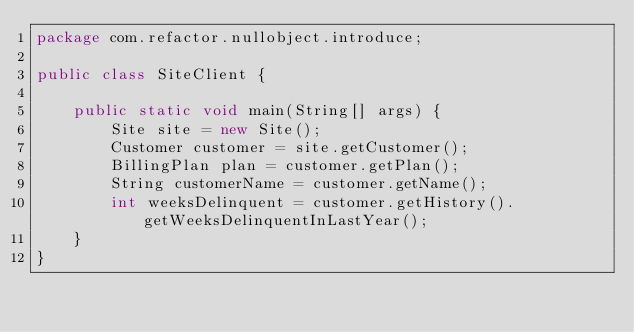<code> <loc_0><loc_0><loc_500><loc_500><_Java_>package com.refactor.nullobject.introduce;

public class SiteClient {

    public static void main(String[] args) {
        Site site = new Site();
        Customer customer = site.getCustomer();
        BillingPlan plan = customer.getPlan();
        String customerName = customer.getName();
        int weeksDelinquent = customer.getHistory().getWeeksDelinquentInLastYear();
    }
}
</code> 